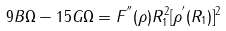<formula> <loc_0><loc_0><loc_500><loc_500>9 B \Omega - 1 5 G \Omega = F ^ { ^ { \prime \prime } } ( \rho ) R _ { 1 } ^ { 2 } [ \rho ^ { ^ { \prime } } ( R _ { 1 } ) ] ^ { 2 }</formula> 